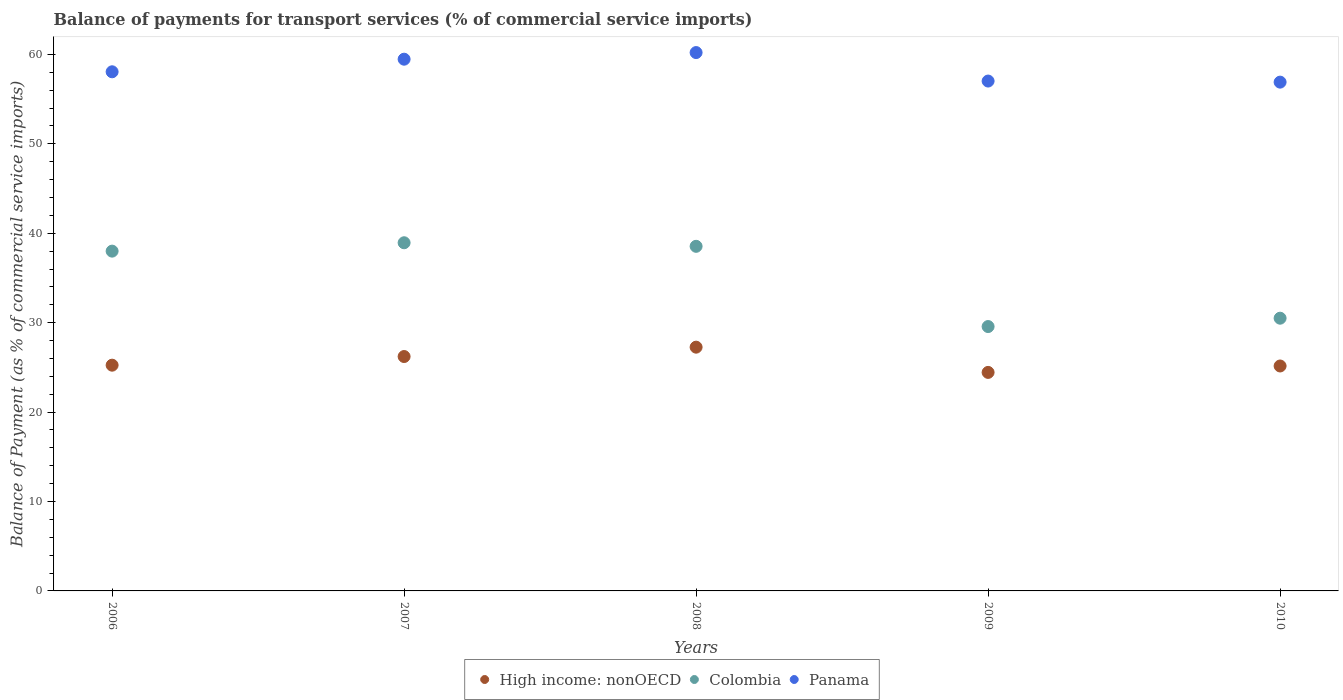Is the number of dotlines equal to the number of legend labels?
Your answer should be compact. Yes. What is the balance of payments for transport services in High income: nonOECD in 2010?
Give a very brief answer. 25.16. Across all years, what is the maximum balance of payments for transport services in Panama?
Offer a terse response. 60.21. Across all years, what is the minimum balance of payments for transport services in Panama?
Provide a short and direct response. 56.9. In which year was the balance of payments for transport services in High income: nonOECD maximum?
Your answer should be compact. 2008. What is the total balance of payments for transport services in Panama in the graph?
Your response must be concise. 291.66. What is the difference between the balance of payments for transport services in Panama in 2007 and that in 2009?
Provide a short and direct response. 2.44. What is the difference between the balance of payments for transport services in Colombia in 2007 and the balance of payments for transport services in High income: nonOECD in 2009?
Offer a terse response. 14.5. What is the average balance of payments for transport services in Panama per year?
Your response must be concise. 58.33. In the year 2010, what is the difference between the balance of payments for transport services in Colombia and balance of payments for transport services in Panama?
Keep it short and to the point. -26.4. In how many years, is the balance of payments for transport services in High income: nonOECD greater than 10 %?
Provide a short and direct response. 5. What is the ratio of the balance of payments for transport services in High income: nonOECD in 2008 to that in 2009?
Your answer should be very brief. 1.12. Is the balance of payments for transport services in Panama in 2006 less than that in 2009?
Offer a very short reply. No. Is the difference between the balance of payments for transport services in Colombia in 2006 and 2009 greater than the difference between the balance of payments for transport services in Panama in 2006 and 2009?
Offer a terse response. Yes. What is the difference between the highest and the second highest balance of payments for transport services in High income: nonOECD?
Provide a short and direct response. 1.05. What is the difference between the highest and the lowest balance of payments for transport services in High income: nonOECD?
Your answer should be compact. 2.82. In how many years, is the balance of payments for transport services in Panama greater than the average balance of payments for transport services in Panama taken over all years?
Your answer should be very brief. 2. Is it the case that in every year, the sum of the balance of payments for transport services in Panama and balance of payments for transport services in High income: nonOECD  is greater than the balance of payments for transport services in Colombia?
Ensure brevity in your answer.  Yes. Is the balance of payments for transport services in Panama strictly less than the balance of payments for transport services in Colombia over the years?
Offer a terse response. No. How many dotlines are there?
Offer a very short reply. 3. Are the values on the major ticks of Y-axis written in scientific E-notation?
Offer a terse response. No. Where does the legend appear in the graph?
Provide a short and direct response. Bottom center. How many legend labels are there?
Your answer should be compact. 3. How are the legend labels stacked?
Your answer should be very brief. Horizontal. What is the title of the graph?
Keep it short and to the point. Balance of payments for transport services (% of commercial service imports). What is the label or title of the X-axis?
Offer a very short reply. Years. What is the label or title of the Y-axis?
Provide a succinct answer. Balance of Payment (as % of commercial service imports). What is the Balance of Payment (as % of commercial service imports) in High income: nonOECD in 2006?
Your answer should be compact. 25.25. What is the Balance of Payment (as % of commercial service imports) in Colombia in 2006?
Your answer should be very brief. 38. What is the Balance of Payment (as % of commercial service imports) of Panama in 2006?
Provide a short and direct response. 58.06. What is the Balance of Payment (as % of commercial service imports) of High income: nonOECD in 2007?
Your answer should be very brief. 26.21. What is the Balance of Payment (as % of commercial service imports) of Colombia in 2007?
Offer a terse response. 38.94. What is the Balance of Payment (as % of commercial service imports) in Panama in 2007?
Ensure brevity in your answer.  59.47. What is the Balance of Payment (as % of commercial service imports) of High income: nonOECD in 2008?
Your answer should be compact. 27.26. What is the Balance of Payment (as % of commercial service imports) of Colombia in 2008?
Offer a terse response. 38.54. What is the Balance of Payment (as % of commercial service imports) of Panama in 2008?
Your answer should be compact. 60.21. What is the Balance of Payment (as % of commercial service imports) in High income: nonOECD in 2009?
Offer a very short reply. 24.44. What is the Balance of Payment (as % of commercial service imports) in Colombia in 2009?
Provide a succinct answer. 29.57. What is the Balance of Payment (as % of commercial service imports) of Panama in 2009?
Provide a succinct answer. 57.02. What is the Balance of Payment (as % of commercial service imports) in High income: nonOECD in 2010?
Make the answer very short. 25.16. What is the Balance of Payment (as % of commercial service imports) in Colombia in 2010?
Offer a very short reply. 30.5. What is the Balance of Payment (as % of commercial service imports) in Panama in 2010?
Your answer should be compact. 56.9. Across all years, what is the maximum Balance of Payment (as % of commercial service imports) in High income: nonOECD?
Offer a terse response. 27.26. Across all years, what is the maximum Balance of Payment (as % of commercial service imports) of Colombia?
Your answer should be compact. 38.94. Across all years, what is the maximum Balance of Payment (as % of commercial service imports) of Panama?
Give a very brief answer. 60.21. Across all years, what is the minimum Balance of Payment (as % of commercial service imports) in High income: nonOECD?
Keep it short and to the point. 24.44. Across all years, what is the minimum Balance of Payment (as % of commercial service imports) of Colombia?
Keep it short and to the point. 29.57. Across all years, what is the minimum Balance of Payment (as % of commercial service imports) in Panama?
Your answer should be compact. 56.9. What is the total Balance of Payment (as % of commercial service imports) in High income: nonOECD in the graph?
Offer a terse response. 128.32. What is the total Balance of Payment (as % of commercial service imports) of Colombia in the graph?
Give a very brief answer. 175.55. What is the total Balance of Payment (as % of commercial service imports) of Panama in the graph?
Your answer should be compact. 291.66. What is the difference between the Balance of Payment (as % of commercial service imports) in High income: nonOECD in 2006 and that in 2007?
Offer a very short reply. -0.97. What is the difference between the Balance of Payment (as % of commercial service imports) of Colombia in 2006 and that in 2007?
Give a very brief answer. -0.94. What is the difference between the Balance of Payment (as % of commercial service imports) in Panama in 2006 and that in 2007?
Keep it short and to the point. -1.41. What is the difference between the Balance of Payment (as % of commercial service imports) of High income: nonOECD in 2006 and that in 2008?
Offer a very short reply. -2.01. What is the difference between the Balance of Payment (as % of commercial service imports) in Colombia in 2006 and that in 2008?
Your response must be concise. -0.54. What is the difference between the Balance of Payment (as % of commercial service imports) of Panama in 2006 and that in 2008?
Provide a succinct answer. -2.15. What is the difference between the Balance of Payment (as % of commercial service imports) in High income: nonOECD in 2006 and that in 2009?
Keep it short and to the point. 0.81. What is the difference between the Balance of Payment (as % of commercial service imports) in Colombia in 2006 and that in 2009?
Your answer should be very brief. 8.43. What is the difference between the Balance of Payment (as % of commercial service imports) of Panama in 2006 and that in 2009?
Your response must be concise. 1.04. What is the difference between the Balance of Payment (as % of commercial service imports) in High income: nonOECD in 2006 and that in 2010?
Offer a very short reply. 0.09. What is the difference between the Balance of Payment (as % of commercial service imports) of Colombia in 2006 and that in 2010?
Provide a short and direct response. 7.5. What is the difference between the Balance of Payment (as % of commercial service imports) of Panama in 2006 and that in 2010?
Give a very brief answer. 1.16. What is the difference between the Balance of Payment (as % of commercial service imports) in High income: nonOECD in 2007 and that in 2008?
Your answer should be very brief. -1.05. What is the difference between the Balance of Payment (as % of commercial service imports) in Colombia in 2007 and that in 2008?
Ensure brevity in your answer.  0.4. What is the difference between the Balance of Payment (as % of commercial service imports) of Panama in 2007 and that in 2008?
Make the answer very short. -0.74. What is the difference between the Balance of Payment (as % of commercial service imports) of High income: nonOECD in 2007 and that in 2009?
Make the answer very short. 1.78. What is the difference between the Balance of Payment (as % of commercial service imports) of Colombia in 2007 and that in 2009?
Your response must be concise. 9.37. What is the difference between the Balance of Payment (as % of commercial service imports) in Panama in 2007 and that in 2009?
Provide a succinct answer. 2.44. What is the difference between the Balance of Payment (as % of commercial service imports) in High income: nonOECD in 2007 and that in 2010?
Your answer should be very brief. 1.06. What is the difference between the Balance of Payment (as % of commercial service imports) in Colombia in 2007 and that in 2010?
Keep it short and to the point. 8.44. What is the difference between the Balance of Payment (as % of commercial service imports) of Panama in 2007 and that in 2010?
Your answer should be very brief. 2.57. What is the difference between the Balance of Payment (as % of commercial service imports) of High income: nonOECD in 2008 and that in 2009?
Provide a short and direct response. 2.82. What is the difference between the Balance of Payment (as % of commercial service imports) of Colombia in 2008 and that in 2009?
Make the answer very short. 8.97. What is the difference between the Balance of Payment (as % of commercial service imports) in Panama in 2008 and that in 2009?
Provide a short and direct response. 3.19. What is the difference between the Balance of Payment (as % of commercial service imports) of High income: nonOECD in 2008 and that in 2010?
Offer a terse response. 2.1. What is the difference between the Balance of Payment (as % of commercial service imports) of Colombia in 2008 and that in 2010?
Your answer should be very brief. 8.04. What is the difference between the Balance of Payment (as % of commercial service imports) of Panama in 2008 and that in 2010?
Provide a short and direct response. 3.31. What is the difference between the Balance of Payment (as % of commercial service imports) in High income: nonOECD in 2009 and that in 2010?
Offer a terse response. -0.72. What is the difference between the Balance of Payment (as % of commercial service imports) in Colombia in 2009 and that in 2010?
Your response must be concise. -0.93. What is the difference between the Balance of Payment (as % of commercial service imports) of Panama in 2009 and that in 2010?
Keep it short and to the point. 0.12. What is the difference between the Balance of Payment (as % of commercial service imports) of High income: nonOECD in 2006 and the Balance of Payment (as % of commercial service imports) of Colombia in 2007?
Ensure brevity in your answer.  -13.69. What is the difference between the Balance of Payment (as % of commercial service imports) of High income: nonOECD in 2006 and the Balance of Payment (as % of commercial service imports) of Panama in 2007?
Give a very brief answer. -34.22. What is the difference between the Balance of Payment (as % of commercial service imports) of Colombia in 2006 and the Balance of Payment (as % of commercial service imports) of Panama in 2007?
Ensure brevity in your answer.  -21.47. What is the difference between the Balance of Payment (as % of commercial service imports) of High income: nonOECD in 2006 and the Balance of Payment (as % of commercial service imports) of Colombia in 2008?
Offer a terse response. -13.29. What is the difference between the Balance of Payment (as % of commercial service imports) in High income: nonOECD in 2006 and the Balance of Payment (as % of commercial service imports) in Panama in 2008?
Offer a very short reply. -34.96. What is the difference between the Balance of Payment (as % of commercial service imports) of Colombia in 2006 and the Balance of Payment (as % of commercial service imports) of Panama in 2008?
Your answer should be compact. -22.21. What is the difference between the Balance of Payment (as % of commercial service imports) in High income: nonOECD in 2006 and the Balance of Payment (as % of commercial service imports) in Colombia in 2009?
Your answer should be very brief. -4.32. What is the difference between the Balance of Payment (as % of commercial service imports) of High income: nonOECD in 2006 and the Balance of Payment (as % of commercial service imports) of Panama in 2009?
Give a very brief answer. -31.78. What is the difference between the Balance of Payment (as % of commercial service imports) in Colombia in 2006 and the Balance of Payment (as % of commercial service imports) in Panama in 2009?
Offer a terse response. -19.02. What is the difference between the Balance of Payment (as % of commercial service imports) of High income: nonOECD in 2006 and the Balance of Payment (as % of commercial service imports) of Colombia in 2010?
Provide a succinct answer. -5.25. What is the difference between the Balance of Payment (as % of commercial service imports) of High income: nonOECD in 2006 and the Balance of Payment (as % of commercial service imports) of Panama in 2010?
Your response must be concise. -31.65. What is the difference between the Balance of Payment (as % of commercial service imports) of Colombia in 2006 and the Balance of Payment (as % of commercial service imports) of Panama in 2010?
Provide a short and direct response. -18.9. What is the difference between the Balance of Payment (as % of commercial service imports) of High income: nonOECD in 2007 and the Balance of Payment (as % of commercial service imports) of Colombia in 2008?
Make the answer very short. -12.33. What is the difference between the Balance of Payment (as % of commercial service imports) in High income: nonOECD in 2007 and the Balance of Payment (as % of commercial service imports) in Panama in 2008?
Give a very brief answer. -33.99. What is the difference between the Balance of Payment (as % of commercial service imports) of Colombia in 2007 and the Balance of Payment (as % of commercial service imports) of Panama in 2008?
Offer a terse response. -21.27. What is the difference between the Balance of Payment (as % of commercial service imports) of High income: nonOECD in 2007 and the Balance of Payment (as % of commercial service imports) of Colombia in 2009?
Offer a very short reply. -3.35. What is the difference between the Balance of Payment (as % of commercial service imports) in High income: nonOECD in 2007 and the Balance of Payment (as % of commercial service imports) in Panama in 2009?
Offer a very short reply. -30.81. What is the difference between the Balance of Payment (as % of commercial service imports) in Colombia in 2007 and the Balance of Payment (as % of commercial service imports) in Panama in 2009?
Your answer should be very brief. -18.09. What is the difference between the Balance of Payment (as % of commercial service imports) in High income: nonOECD in 2007 and the Balance of Payment (as % of commercial service imports) in Colombia in 2010?
Provide a succinct answer. -4.29. What is the difference between the Balance of Payment (as % of commercial service imports) in High income: nonOECD in 2007 and the Balance of Payment (as % of commercial service imports) in Panama in 2010?
Offer a terse response. -30.69. What is the difference between the Balance of Payment (as % of commercial service imports) of Colombia in 2007 and the Balance of Payment (as % of commercial service imports) of Panama in 2010?
Your answer should be very brief. -17.96. What is the difference between the Balance of Payment (as % of commercial service imports) of High income: nonOECD in 2008 and the Balance of Payment (as % of commercial service imports) of Colombia in 2009?
Make the answer very short. -2.31. What is the difference between the Balance of Payment (as % of commercial service imports) in High income: nonOECD in 2008 and the Balance of Payment (as % of commercial service imports) in Panama in 2009?
Your response must be concise. -29.76. What is the difference between the Balance of Payment (as % of commercial service imports) of Colombia in 2008 and the Balance of Payment (as % of commercial service imports) of Panama in 2009?
Give a very brief answer. -18.48. What is the difference between the Balance of Payment (as % of commercial service imports) of High income: nonOECD in 2008 and the Balance of Payment (as % of commercial service imports) of Colombia in 2010?
Offer a very short reply. -3.24. What is the difference between the Balance of Payment (as % of commercial service imports) of High income: nonOECD in 2008 and the Balance of Payment (as % of commercial service imports) of Panama in 2010?
Keep it short and to the point. -29.64. What is the difference between the Balance of Payment (as % of commercial service imports) of Colombia in 2008 and the Balance of Payment (as % of commercial service imports) of Panama in 2010?
Give a very brief answer. -18.36. What is the difference between the Balance of Payment (as % of commercial service imports) in High income: nonOECD in 2009 and the Balance of Payment (as % of commercial service imports) in Colombia in 2010?
Provide a short and direct response. -6.06. What is the difference between the Balance of Payment (as % of commercial service imports) of High income: nonOECD in 2009 and the Balance of Payment (as % of commercial service imports) of Panama in 2010?
Your answer should be compact. -32.46. What is the difference between the Balance of Payment (as % of commercial service imports) of Colombia in 2009 and the Balance of Payment (as % of commercial service imports) of Panama in 2010?
Your answer should be compact. -27.34. What is the average Balance of Payment (as % of commercial service imports) in High income: nonOECD per year?
Your answer should be compact. 25.66. What is the average Balance of Payment (as % of commercial service imports) of Colombia per year?
Your answer should be compact. 35.11. What is the average Balance of Payment (as % of commercial service imports) in Panama per year?
Your answer should be compact. 58.33. In the year 2006, what is the difference between the Balance of Payment (as % of commercial service imports) of High income: nonOECD and Balance of Payment (as % of commercial service imports) of Colombia?
Offer a very short reply. -12.75. In the year 2006, what is the difference between the Balance of Payment (as % of commercial service imports) in High income: nonOECD and Balance of Payment (as % of commercial service imports) in Panama?
Provide a short and direct response. -32.81. In the year 2006, what is the difference between the Balance of Payment (as % of commercial service imports) of Colombia and Balance of Payment (as % of commercial service imports) of Panama?
Your answer should be compact. -20.06. In the year 2007, what is the difference between the Balance of Payment (as % of commercial service imports) in High income: nonOECD and Balance of Payment (as % of commercial service imports) in Colombia?
Give a very brief answer. -12.72. In the year 2007, what is the difference between the Balance of Payment (as % of commercial service imports) of High income: nonOECD and Balance of Payment (as % of commercial service imports) of Panama?
Offer a terse response. -33.25. In the year 2007, what is the difference between the Balance of Payment (as % of commercial service imports) of Colombia and Balance of Payment (as % of commercial service imports) of Panama?
Provide a succinct answer. -20.53. In the year 2008, what is the difference between the Balance of Payment (as % of commercial service imports) in High income: nonOECD and Balance of Payment (as % of commercial service imports) in Colombia?
Your answer should be compact. -11.28. In the year 2008, what is the difference between the Balance of Payment (as % of commercial service imports) of High income: nonOECD and Balance of Payment (as % of commercial service imports) of Panama?
Your answer should be compact. -32.95. In the year 2008, what is the difference between the Balance of Payment (as % of commercial service imports) of Colombia and Balance of Payment (as % of commercial service imports) of Panama?
Your answer should be compact. -21.67. In the year 2009, what is the difference between the Balance of Payment (as % of commercial service imports) of High income: nonOECD and Balance of Payment (as % of commercial service imports) of Colombia?
Your response must be concise. -5.13. In the year 2009, what is the difference between the Balance of Payment (as % of commercial service imports) in High income: nonOECD and Balance of Payment (as % of commercial service imports) in Panama?
Give a very brief answer. -32.58. In the year 2009, what is the difference between the Balance of Payment (as % of commercial service imports) in Colombia and Balance of Payment (as % of commercial service imports) in Panama?
Give a very brief answer. -27.46. In the year 2010, what is the difference between the Balance of Payment (as % of commercial service imports) of High income: nonOECD and Balance of Payment (as % of commercial service imports) of Colombia?
Keep it short and to the point. -5.34. In the year 2010, what is the difference between the Balance of Payment (as % of commercial service imports) in High income: nonOECD and Balance of Payment (as % of commercial service imports) in Panama?
Your response must be concise. -31.75. In the year 2010, what is the difference between the Balance of Payment (as % of commercial service imports) in Colombia and Balance of Payment (as % of commercial service imports) in Panama?
Give a very brief answer. -26.4. What is the ratio of the Balance of Payment (as % of commercial service imports) of High income: nonOECD in 2006 to that in 2007?
Provide a succinct answer. 0.96. What is the ratio of the Balance of Payment (as % of commercial service imports) in Colombia in 2006 to that in 2007?
Your answer should be very brief. 0.98. What is the ratio of the Balance of Payment (as % of commercial service imports) of Panama in 2006 to that in 2007?
Keep it short and to the point. 0.98. What is the ratio of the Balance of Payment (as % of commercial service imports) of High income: nonOECD in 2006 to that in 2008?
Provide a short and direct response. 0.93. What is the ratio of the Balance of Payment (as % of commercial service imports) in Colombia in 2006 to that in 2008?
Your answer should be very brief. 0.99. What is the ratio of the Balance of Payment (as % of commercial service imports) of High income: nonOECD in 2006 to that in 2009?
Keep it short and to the point. 1.03. What is the ratio of the Balance of Payment (as % of commercial service imports) of Colombia in 2006 to that in 2009?
Provide a succinct answer. 1.29. What is the ratio of the Balance of Payment (as % of commercial service imports) in Panama in 2006 to that in 2009?
Keep it short and to the point. 1.02. What is the ratio of the Balance of Payment (as % of commercial service imports) of Colombia in 2006 to that in 2010?
Your answer should be very brief. 1.25. What is the ratio of the Balance of Payment (as % of commercial service imports) of Panama in 2006 to that in 2010?
Offer a very short reply. 1.02. What is the ratio of the Balance of Payment (as % of commercial service imports) of High income: nonOECD in 2007 to that in 2008?
Provide a short and direct response. 0.96. What is the ratio of the Balance of Payment (as % of commercial service imports) of Colombia in 2007 to that in 2008?
Your response must be concise. 1.01. What is the ratio of the Balance of Payment (as % of commercial service imports) of Panama in 2007 to that in 2008?
Keep it short and to the point. 0.99. What is the ratio of the Balance of Payment (as % of commercial service imports) in High income: nonOECD in 2007 to that in 2009?
Make the answer very short. 1.07. What is the ratio of the Balance of Payment (as % of commercial service imports) in Colombia in 2007 to that in 2009?
Ensure brevity in your answer.  1.32. What is the ratio of the Balance of Payment (as % of commercial service imports) of Panama in 2007 to that in 2009?
Provide a short and direct response. 1.04. What is the ratio of the Balance of Payment (as % of commercial service imports) in High income: nonOECD in 2007 to that in 2010?
Make the answer very short. 1.04. What is the ratio of the Balance of Payment (as % of commercial service imports) in Colombia in 2007 to that in 2010?
Offer a very short reply. 1.28. What is the ratio of the Balance of Payment (as % of commercial service imports) of Panama in 2007 to that in 2010?
Make the answer very short. 1.05. What is the ratio of the Balance of Payment (as % of commercial service imports) in High income: nonOECD in 2008 to that in 2009?
Make the answer very short. 1.12. What is the ratio of the Balance of Payment (as % of commercial service imports) of Colombia in 2008 to that in 2009?
Make the answer very short. 1.3. What is the ratio of the Balance of Payment (as % of commercial service imports) in Panama in 2008 to that in 2009?
Give a very brief answer. 1.06. What is the ratio of the Balance of Payment (as % of commercial service imports) in High income: nonOECD in 2008 to that in 2010?
Offer a very short reply. 1.08. What is the ratio of the Balance of Payment (as % of commercial service imports) in Colombia in 2008 to that in 2010?
Offer a terse response. 1.26. What is the ratio of the Balance of Payment (as % of commercial service imports) in Panama in 2008 to that in 2010?
Offer a terse response. 1.06. What is the ratio of the Balance of Payment (as % of commercial service imports) in High income: nonOECD in 2009 to that in 2010?
Make the answer very short. 0.97. What is the ratio of the Balance of Payment (as % of commercial service imports) of Colombia in 2009 to that in 2010?
Ensure brevity in your answer.  0.97. What is the ratio of the Balance of Payment (as % of commercial service imports) of Panama in 2009 to that in 2010?
Keep it short and to the point. 1. What is the difference between the highest and the second highest Balance of Payment (as % of commercial service imports) in High income: nonOECD?
Give a very brief answer. 1.05. What is the difference between the highest and the second highest Balance of Payment (as % of commercial service imports) of Colombia?
Give a very brief answer. 0.4. What is the difference between the highest and the second highest Balance of Payment (as % of commercial service imports) of Panama?
Make the answer very short. 0.74. What is the difference between the highest and the lowest Balance of Payment (as % of commercial service imports) in High income: nonOECD?
Give a very brief answer. 2.82. What is the difference between the highest and the lowest Balance of Payment (as % of commercial service imports) in Colombia?
Your answer should be compact. 9.37. What is the difference between the highest and the lowest Balance of Payment (as % of commercial service imports) of Panama?
Your answer should be compact. 3.31. 